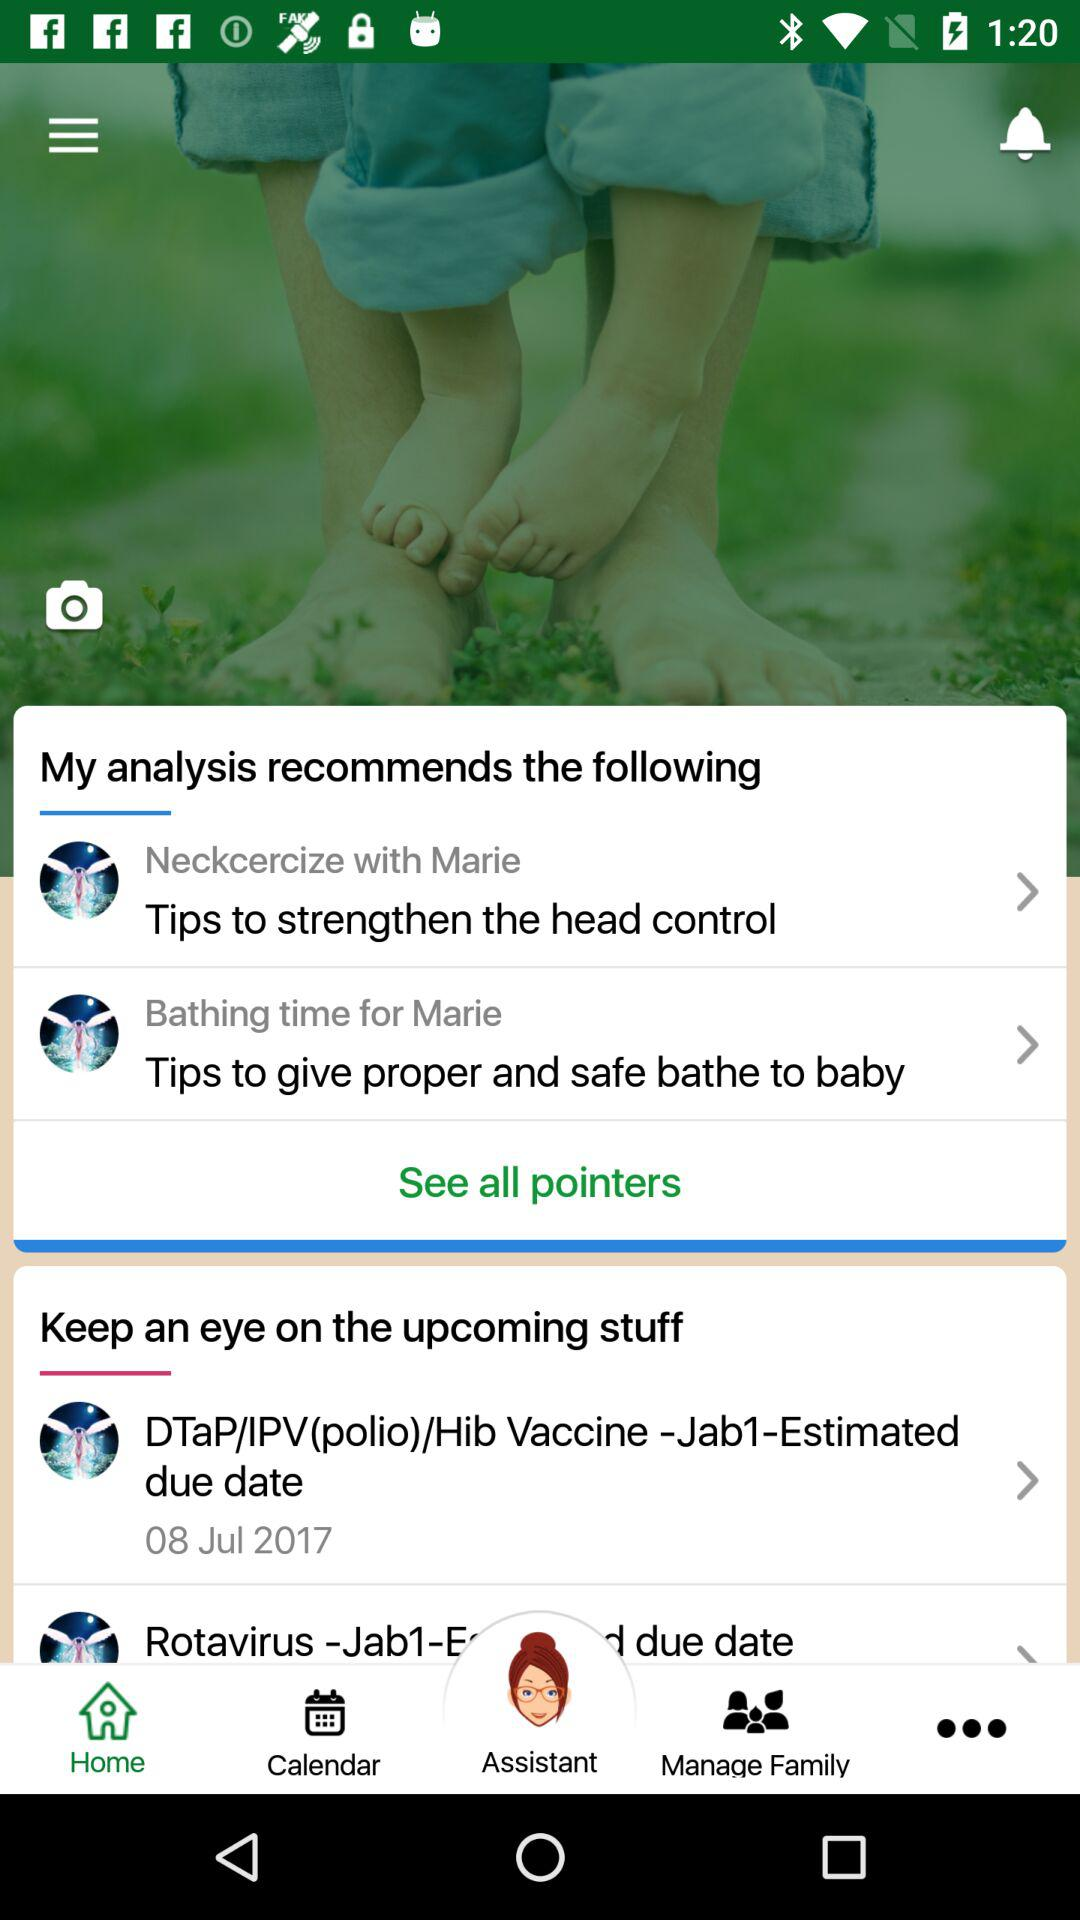Which tab am I using? You are using the "Home" tab. 